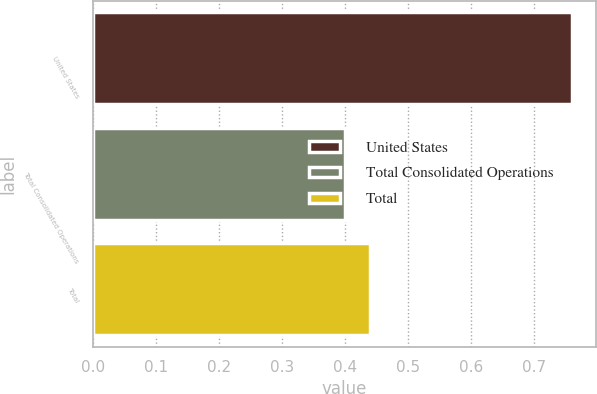<chart> <loc_0><loc_0><loc_500><loc_500><bar_chart><fcel>United States<fcel>Total Consolidated Operations<fcel>Total<nl><fcel>0.76<fcel>0.4<fcel>0.44<nl></chart> 